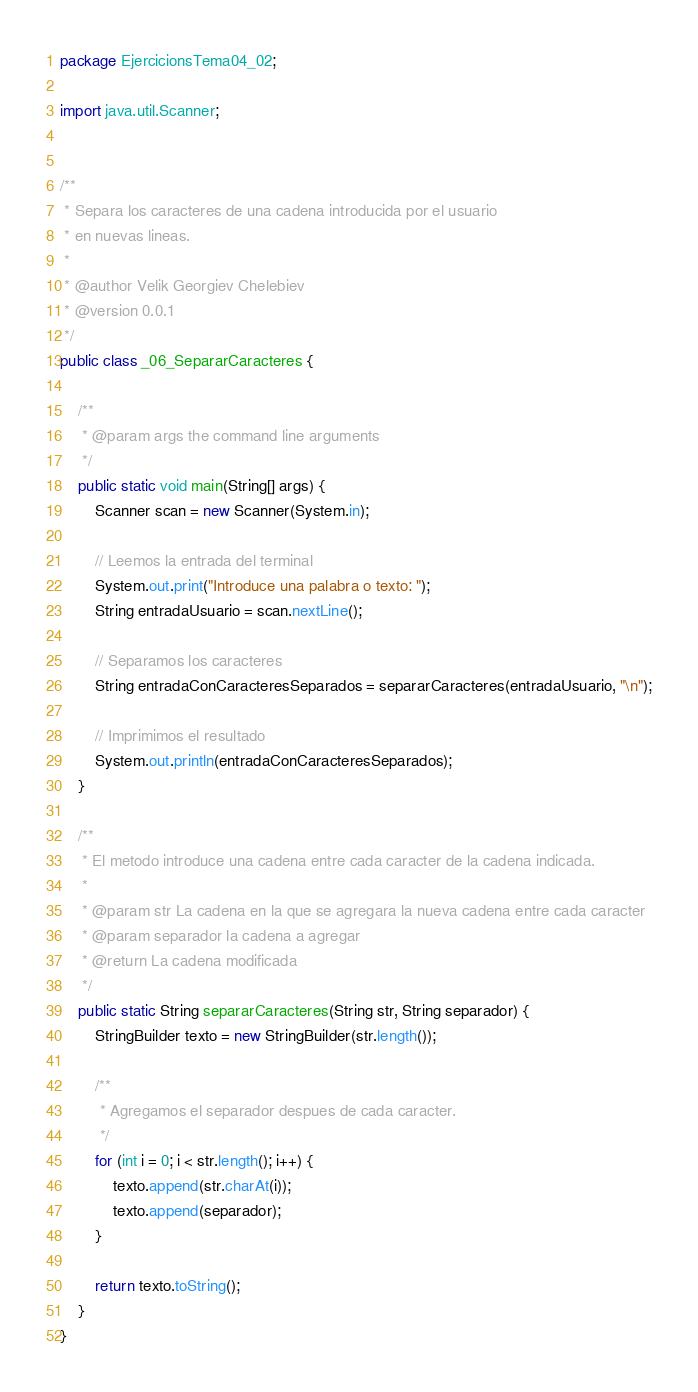Convert code to text. <code><loc_0><loc_0><loc_500><loc_500><_Java_>package EjercicionsTema04_02;

import java.util.Scanner;


/**
 * Separa los caracteres de una cadena introducida por el usuario
 * en nuevas lineas.
 * 
 * @author Velik Georgiev Chelebiev
 * @version 0.0.1
 */
public class _06_SepararCaracteres {

    /**
     * @param args the command line arguments
     */
    public static void main(String[] args) {
        Scanner scan = new Scanner(System.in);

        // Leemos la entrada del terminal
        System.out.print("Introduce una palabra o texto: ");
        String entradaUsuario = scan.nextLine();

        // Separamos los caracteres
        String entradaConCaracteresSeparados = separarCaracteres(entradaUsuario, "\n");

        // Imprimimos el resultado
        System.out.println(entradaConCaracteresSeparados);
    }

    /**
     * El metodo introduce una cadena entre cada caracter de la cadena indicada.
     *
     * @param str La cadena en la que se agregara la nueva cadena entre cada caracter
     * @param separador la cadena a agregar
     * @return La cadena modificada
     */
    public static String separarCaracteres(String str, String separador) {
        StringBuilder texto = new StringBuilder(str.length());
        
        /**
         * Agregamos el separador despues de cada caracter.
         */
        for (int i = 0; i < str.length(); i++) {
            texto.append(str.charAt(i));
            texto.append(separador);
        }

        return texto.toString();
    }
}
</code> 